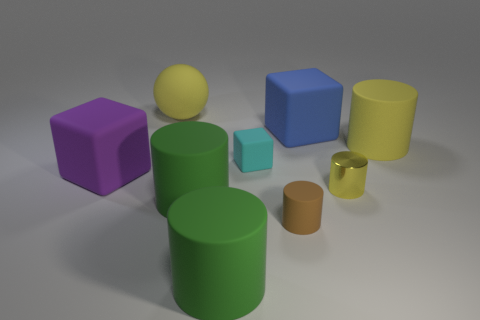How many yellow cylinders must be subtracted to get 1 yellow cylinders? 1 Subtract all small cyan blocks. How many blocks are left? 2 Subtract 2 cylinders. How many cylinders are left? 3 Subtract all green cylinders. How many blue blocks are left? 1 Add 3 yellow matte cylinders. How many yellow matte cylinders exist? 4 Add 1 matte cylinders. How many objects exist? 10 Subtract all yellow cylinders. How many cylinders are left? 3 Subtract 0 green blocks. How many objects are left? 9 Subtract all cylinders. How many objects are left? 4 Subtract all purple spheres. Subtract all green cubes. How many spheres are left? 1 